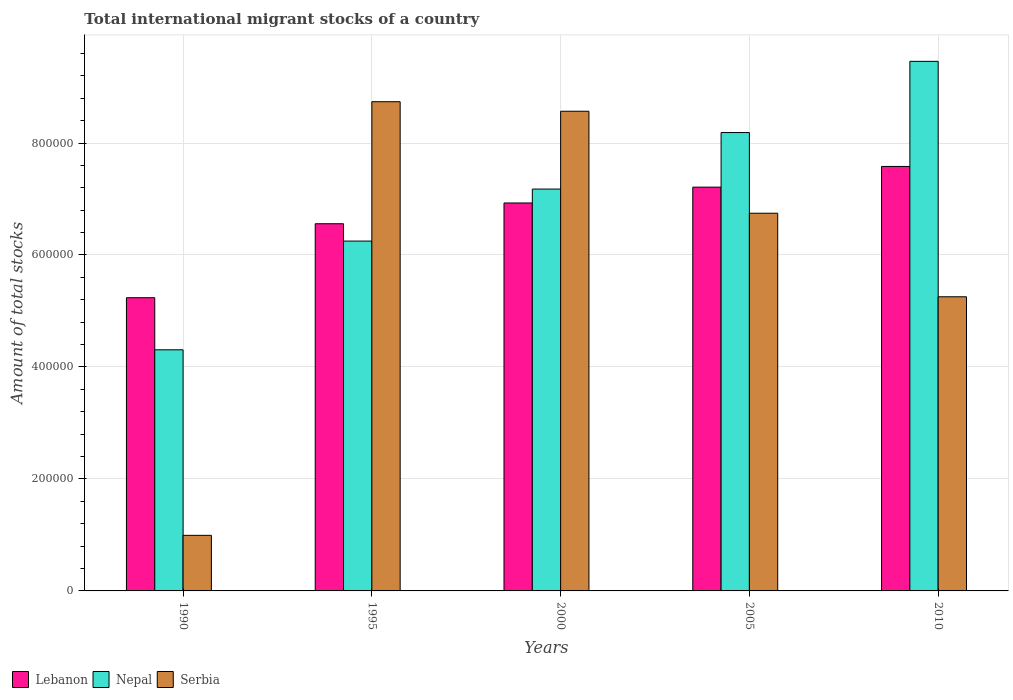How many different coloured bars are there?
Give a very brief answer. 3. How many groups of bars are there?
Your answer should be compact. 5. Are the number of bars on each tick of the X-axis equal?
Your response must be concise. Yes. How many bars are there on the 4th tick from the left?
Give a very brief answer. 3. How many bars are there on the 2nd tick from the right?
Offer a very short reply. 3. What is the amount of total stocks in in Nepal in 2010?
Offer a very short reply. 9.46e+05. Across all years, what is the maximum amount of total stocks in in Serbia?
Give a very brief answer. 8.74e+05. Across all years, what is the minimum amount of total stocks in in Lebanon?
Provide a succinct answer. 5.24e+05. In which year was the amount of total stocks in in Serbia minimum?
Ensure brevity in your answer.  1990. What is the total amount of total stocks in in Nepal in the graph?
Your response must be concise. 3.54e+06. What is the difference between the amount of total stocks in in Serbia in 1995 and that in 2010?
Offer a terse response. 3.48e+05. What is the difference between the amount of total stocks in in Serbia in 2010 and the amount of total stocks in in Lebanon in 1990?
Your answer should be very brief. 1695. What is the average amount of total stocks in in Serbia per year?
Offer a terse response. 6.06e+05. In the year 2000, what is the difference between the amount of total stocks in in Lebanon and amount of total stocks in in Nepal?
Provide a short and direct response. -2.48e+04. What is the ratio of the amount of total stocks in in Serbia in 1990 to that in 1995?
Provide a succinct answer. 0.11. Is the amount of total stocks in in Lebanon in 1990 less than that in 2000?
Your answer should be very brief. Yes. Is the difference between the amount of total stocks in in Lebanon in 1995 and 2010 greater than the difference between the amount of total stocks in in Nepal in 1995 and 2010?
Give a very brief answer. Yes. What is the difference between the highest and the second highest amount of total stocks in in Lebanon?
Give a very brief answer. 3.70e+04. What is the difference between the highest and the lowest amount of total stocks in in Lebanon?
Your answer should be very brief. 2.34e+05. In how many years, is the amount of total stocks in in Serbia greater than the average amount of total stocks in in Serbia taken over all years?
Offer a very short reply. 3. Is the sum of the amount of total stocks in in Nepal in 1990 and 2010 greater than the maximum amount of total stocks in in Lebanon across all years?
Your answer should be very brief. Yes. What does the 2nd bar from the left in 2005 represents?
Offer a terse response. Nepal. What does the 1st bar from the right in 1990 represents?
Provide a short and direct response. Serbia. Is it the case that in every year, the sum of the amount of total stocks in in Serbia and amount of total stocks in in Nepal is greater than the amount of total stocks in in Lebanon?
Give a very brief answer. Yes. Are all the bars in the graph horizontal?
Provide a succinct answer. No. Does the graph contain any zero values?
Offer a very short reply. No. Does the graph contain grids?
Provide a short and direct response. Yes. Where does the legend appear in the graph?
Make the answer very short. Bottom left. How many legend labels are there?
Give a very brief answer. 3. How are the legend labels stacked?
Your answer should be very brief. Horizontal. What is the title of the graph?
Your response must be concise. Total international migrant stocks of a country. What is the label or title of the X-axis?
Your response must be concise. Years. What is the label or title of the Y-axis?
Make the answer very short. Amount of total stocks. What is the Amount of total stocks in Lebanon in 1990?
Offer a very short reply. 5.24e+05. What is the Amount of total stocks in Nepal in 1990?
Ensure brevity in your answer.  4.31e+05. What is the Amount of total stocks of Serbia in 1990?
Offer a very short reply. 9.93e+04. What is the Amount of total stocks in Lebanon in 1995?
Ensure brevity in your answer.  6.56e+05. What is the Amount of total stocks in Nepal in 1995?
Give a very brief answer. 6.25e+05. What is the Amount of total stocks of Serbia in 1995?
Provide a succinct answer. 8.74e+05. What is the Amount of total stocks in Lebanon in 2000?
Provide a short and direct response. 6.93e+05. What is the Amount of total stocks in Nepal in 2000?
Give a very brief answer. 7.18e+05. What is the Amount of total stocks in Serbia in 2000?
Provide a succinct answer. 8.57e+05. What is the Amount of total stocks in Lebanon in 2005?
Offer a terse response. 7.21e+05. What is the Amount of total stocks of Nepal in 2005?
Provide a succinct answer. 8.19e+05. What is the Amount of total stocks of Serbia in 2005?
Your answer should be very brief. 6.75e+05. What is the Amount of total stocks of Lebanon in 2010?
Provide a short and direct response. 7.58e+05. What is the Amount of total stocks of Nepal in 2010?
Make the answer very short. 9.46e+05. What is the Amount of total stocks of Serbia in 2010?
Provide a short and direct response. 5.25e+05. Across all years, what is the maximum Amount of total stocks in Lebanon?
Provide a short and direct response. 7.58e+05. Across all years, what is the maximum Amount of total stocks in Nepal?
Provide a short and direct response. 9.46e+05. Across all years, what is the maximum Amount of total stocks in Serbia?
Provide a short and direct response. 8.74e+05. Across all years, what is the minimum Amount of total stocks in Lebanon?
Your response must be concise. 5.24e+05. Across all years, what is the minimum Amount of total stocks in Nepal?
Give a very brief answer. 4.31e+05. Across all years, what is the minimum Amount of total stocks in Serbia?
Offer a very short reply. 9.93e+04. What is the total Amount of total stocks in Lebanon in the graph?
Keep it short and to the point. 3.35e+06. What is the total Amount of total stocks in Nepal in the graph?
Provide a succinct answer. 3.54e+06. What is the total Amount of total stocks in Serbia in the graph?
Provide a short and direct response. 3.03e+06. What is the difference between the Amount of total stocks of Lebanon in 1990 and that in 1995?
Give a very brief answer. -1.32e+05. What is the difference between the Amount of total stocks of Nepal in 1990 and that in 1995?
Offer a very short reply. -1.94e+05. What is the difference between the Amount of total stocks of Serbia in 1990 and that in 1995?
Your answer should be compact. -7.75e+05. What is the difference between the Amount of total stocks of Lebanon in 1990 and that in 2000?
Provide a short and direct response. -1.69e+05. What is the difference between the Amount of total stocks in Nepal in 1990 and that in 2000?
Provide a short and direct response. -2.87e+05. What is the difference between the Amount of total stocks of Serbia in 1990 and that in 2000?
Your answer should be very brief. -7.57e+05. What is the difference between the Amount of total stocks in Lebanon in 1990 and that in 2005?
Keep it short and to the point. -1.97e+05. What is the difference between the Amount of total stocks of Nepal in 1990 and that in 2005?
Give a very brief answer. -3.88e+05. What is the difference between the Amount of total stocks in Serbia in 1990 and that in 2005?
Give a very brief answer. -5.75e+05. What is the difference between the Amount of total stocks of Lebanon in 1990 and that in 2010?
Your response must be concise. -2.34e+05. What is the difference between the Amount of total stocks in Nepal in 1990 and that in 2010?
Offer a terse response. -5.15e+05. What is the difference between the Amount of total stocks of Serbia in 1990 and that in 2010?
Your response must be concise. -4.26e+05. What is the difference between the Amount of total stocks in Lebanon in 1995 and that in 2000?
Offer a very short reply. -3.71e+04. What is the difference between the Amount of total stocks of Nepal in 1995 and that in 2000?
Keep it short and to the point. -9.29e+04. What is the difference between the Amount of total stocks of Serbia in 1995 and that in 2000?
Your answer should be compact. 1.70e+04. What is the difference between the Amount of total stocks of Lebanon in 1995 and that in 2005?
Keep it short and to the point. -6.54e+04. What is the difference between the Amount of total stocks in Nepal in 1995 and that in 2005?
Keep it short and to the point. -1.94e+05. What is the difference between the Amount of total stocks in Serbia in 1995 and that in 2005?
Offer a terse response. 1.99e+05. What is the difference between the Amount of total stocks in Lebanon in 1995 and that in 2010?
Your answer should be compact. -1.02e+05. What is the difference between the Amount of total stocks in Nepal in 1995 and that in 2010?
Provide a short and direct response. -3.21e+05. What is the difference between the Amount of total stocks in Serbia in 1995 and that in 2010?
Offer a terse response. 3.48e+05. What is the difference between the Amount of total stocks of Lebanon in 2000 and that in 2005?
Give a very brief answer. -2.83e+04. What is the difference between the Amount of total stocks in Nepal in 2000 and that in 2005?
Offer a very short reply. -1.01e+05. What is the difference between the Amount of total stocks in Serbia in 2000 and that in 2005?
Make the answer very short. 1.82e+05. What is the difference between the Amount of total stocks of Lebanon in 2000 and that in 2010?
Keep it short and to the point. -6.53e+04. What is the difference between the Amount of total stocks in Nepal in 2000 and that in 2010?
Ensure brevity in your answer.  -2.28e+05. What is the difference between the Amount of total stocks in Serbia in 2000 and that in 2010?
Keep it short and to the point. 3.31e+05. What is the difference between the Amount of total stocks in Lebanon in 2005 and that in 2010?
Provide a short and direct response. -3.70e+04. What is the difference between the Amount of total stocks of Nepal in 2005 and that in 2010?
Your answer should be very brief. -1.27e+05. What is the difference between the Amount of total stocks of Serbia in 2005 and that in 2010?
Provide a succinct answer. 1.49e+05. What is the difference between the Amount of total stocks of Lebanon in 1990 and the Amount of total stocks of Nepal in 1995?
Your answer should be compact. -1.01e+05. What is the difference between the Amount of total stocks in Lebanon in 1990 and the Amount of total stocks in Serbia in 1995?
Provide a succinct answer. -3.50e+05. What is the difference between the Amount of total stocks in Nepal in 1990 and the Amount of total stocks in Serbia in 1995?
Your answer should be compact. -4.43e+05. What is the difference between the Amount of total stocks of Lebanon in 1990 and the Amount of total stocks of Nepal in 2000?
Provide a succinct answer. -1.94e+05. What is the difference between the Amount of total stocks of Lebanon in 1990 and the Amount of total stocks of Serbia in 2000?
Make the answer very short. -3.33e+05. What is the difference between the Amount of total stocks of Nepal in 1990 and the Amount of total stocks of Serbia in 2000?
Ensure brevity in your answer.  -4.26e+05. What is the difference between the Amount of total stocks of Lebanon in 1990 and the Amount of total stocks of Nepal in 2005?
Offer a terse response. -2.95e+05. What is the difference between the Amount of total stocks in Lebanon in 1990 and the Amount of total stocks in Serbia in 2005?
Offer a very short reply. -1.51e+05. What is the difference between the Amount of total stocks of Nepal in 1990 and the Amount of total stocks of Serbia in 2005?
Offer a terse response. -2.44e+05. What is the difference between the Amount of total stocks in Lebanon in 1990 and the Amount of total stocks in Nepal in 2010?
Provide a succinct answer. -4.22e+05. What is the difference between the Amount of total stocks in Lebanon in 1990 and the Amount of total stocks in Serbia in 2010?
Your answer should be very brief. -1695. What is the difference between the Amount of total stocks in Nepal in 1990 and the Amount of total stocks in Serbia in 2010?
Give a very brief answer. -9.47e+04. What is the difference between the Amount of total stocks of Lebanon in 1995 and the Amount of total stocks of Nepal in 2000?
Provide a succinct answer. -6.19e+04. What is the difference between the Amount of total stocks of Lebanon in 1995 and the Amount of total stocks of Serbia in 2000?
Provide a succinct answer. -2.01e+05. What is the difference between the Amount of total stocks of Nepal in 1995 and the Amount of total stocks of Serbia in 2000?
Your answer should be very brief. -2.32e+05. What is the difference between the Amount of total stocks of Lebanon in 1995 and the Amount of total stocks of Nepal in 2005?
Give a very brief answer. -1.63e+05. What is the difference between the Amount of total stocks in Lebanon in 1995 and the Amount of total stocks in Serbia in 2005?
Offer a very short reply. -1.88e+04. What is the difference between the Amount of total stocks of Nepal in 1995 and the Amount of total stocks of Serbia in 2005?
Offer a terse response. -4.97e+04. What is the difference between the Amount of total stocks in Lebanon in 1995 and the Amount of total stocks in Nepal in 2010?
Offer a very short reply. -2.90e+05. What is the difference between the Amount of total stocks in Lebanon in 1995 and the Amount of total stocks in Serbia in 2010?
Make the answer very short. 1.30e+05. What is the difference between the Amount of total stocks of Nepal in 1995 and the Amount of total stocks of Serbia in 2010?
Your answer should be compact. 9.95e+04. What is the difference between the Amount of total stocks of Lebanon in 2000 and the Amount of total stocks of Nepal in 2005?
Ensure brevity in your answer.  -1.26e+05. What is the difference between the Amount of total stocks of Lebanon in 2000 and the Amount of total stocks of Serbia in 2005?
Provide a succinct answer. 1.83e+04. What is the difference between the Amount of total stocks in Nepal in 2000 and the Amount of total stocks in Serbia in 2005?
Your answer should be compact. 4.31e+04. What is the difference between the Amount of total stocks of Lebanon in 2000 and the Amount of total stocks of Nepal in 2010?
Ensure brevity in your answer.  -2.53e+05. What is the difference between the Amount of total stocks in Lebanon in 2000 and the Amount of total stocks in Serbia in 2010?
Ensure brevity in your answer.  1.68e+05. What is the difference between the Amount of total stocks in Nepal in 2000 and the Amount of total stocks in Serbia in 2010?
Your answer should be compact. 1.92e+05. What is the difference between the Amount of total stocks in Lebanon in 2005 and the Amount of total stocks in Nepal in 2010?
Offer a terse response. -2.25e+05. What is the difference between the Amount of total stocks of Lebanon in 2005 and the Amount of total stocks of Serbia in 2010?
Your answer should be compact. 1.96e+05. What is the difference between the Amount of total stocks of Nepal in 2005 and the Amount of total stocks of Serbia in 2010?
Make the answer very short. 2.93e+05. What is the average Amount of total stocks in Lebanon per year?
Ensure brevity in your answer.  6.70e+05. What is the average Amount of total stocks in Nepal per year?
Your response must be concise. 7.08e+05. What is the average Amount of total stocks in Serbia per year?
Provide a succinct answer. 6.06e+05. In the year 1990, what is the difference between the Amount of total stocks of Lebanon and Amount of total stocks of Nepal?
Keep it short and to the point. 9.30e+04. In the year 1990, what is the difference between the Amount of total stocks of Lebanon and Amount of total stocks of Serbia?
Give a very brief answer. 4.24e+05. In the year 1990, what is the difference between the Amount of total stocks in Nepal and Amount of total stocks in Serbia?
Ensure brevity in your answer.  3.31e+05. In the year 1995, what is the difference between the Amount of total stocks in Lebanon and Amount of total stocks in Nepal?
Give a very brief answer. 3.10e+04. In the year 1995, what is the difference between the Amount of total stocks of Lebanon and Amount of total stocks of Serbia?
Ensure brevity in your answer.  -2.18e+05. In the year 1995, what is the difference between the Amount of total stocks of Nepal and Amount of total stocks of Serbia?
Provide a short and direct response. -2.49e+05. In the year 2000, what is the difference between the Amount of total stocks of Lebanon and Amount of total stocks of Nepal?
Your answer should be compact. -2.48e+04. In the year 2000, what is the difference between the Amount of total stocks in Lebanon and Amount of total stocks in Serbia?
Offer a terse response. -1.64e+05. In the year 2000, what is the difference between the Amount of total stocks in Nepal and Amount of total stocks in Serbia?
Give a very brief answer. -1.39e+05. In the year 2005, what is the difference between the Amount of total stocks of Lebanon and Amount of total stocks of Nepal?
Provide a short and direct response. -9.75e+04. In the year 2005, what is the difference between the Amount of total stocks in Lebanon and Amount of total stocks in Serbia?
Your response must be concise. 4.66e+04. In the year 2005, what is the difference between the Amount of total stocks of Nepal and Amount of total stocks of Serbia?
Offer a very short reply. 1.44e+05. In the year 2010, what is the difference between the Amount of total stocks in Lebanon and Amount of total stocks in Nepal?
Your answer should be very brief. -1.88e+05. In the year 2010, what is the difference between the Amount of total stocks of Lebanon and Amount of total stocks of Serbia?
Ensure brevity in your answer.  2.33e+05. In the year 2010, what is the difference between the Amount of total stocks in Nepal and Amount of total stocks in Serbia?
Keep it short and to the point. 4.20e+05. What is the ratio of the Amount of total stocks in Lebanon in 1990 to that in 1995?
Your answer should be very brief. 0.8. What is the ratio of the Amount of total stocks in Nepal in 1990 to that in 1995?
Your answer should be very brief. 0.69. What is the ratio of the Amount of total stocks of Serbia in 1990 to that in 1995?
Offer a terse response. 0.11. What is the ratio of the Amount of total stocks in Lebanon in 1990 to that in 2000?
Your answer should be compact. 0.76. What is the ratio of the Amount of total stocks of Serbia in 1990 to that in 2000?
Give a very brief answer. 0.12. What is the ratio of the Amount of total stocks in Lebanon in 1990 to that in 2005?
Your answer should be compact. 0.73. What is the ratio of the Amount of total stocks in Nepal in 1990 to that in 2005?
Keep it short and to the point. 0.53. What is the ratio of the Amount of total stocks in Serbia in 1990 to that in 2005?
Your answer should be compact. 0.15. What is the ratio of the Amount of total stocks of Lebanon in 1990 to that in 2010?
Ensure brevity in your answer.  0.69. What is the ratio of the Amount of total stocks of Nepal in 1990 to that in 2010?
Your answer should be very brief. 0.46. What is the ratio of the Amount of total stocks of Serbia in 1990 to that in 2010?
Your response must be concise. 0.19. What is the ratio of the Amount of total stocks of Lebanon in 1995 to that in 2000?
Ensure brevity in your answer.  0.95. What is the ratio of the Amount of total stocks in Nepal in 1995 to that in 2000?
Ensure brevity in your answer.  0.87. What is the ratio of the Amount of total stocks in Serbia in 1995 to that in 2000?
Provide a succinct answer. 1.02. What is the ratio of the Amount of total stocks in Lebanon in 1995 to that in 2005?
Your response must be concise. 0.91. What is the ratio of the Amount of total stocks of Nepal in 1995 to that in 2005?
Your response must be concise. 0.76. What is the ratio of the Amount of total stocks of Serbia in 1995 to that in 2005?
Offer a very short reply. 1.3. What is the ratio of the Amount of total stocks in Lebanon in 1995 to that in 2010?
Give a very brief answer. 0.86. What is the ratio of the Amount of total stocks in Nepal in 1995 to that in 2010?
Keep it short and to the point. 0.66. What is the ratio of the Amount of total stocks of Serbia in 1995 to that in 2010?
Your response must be concise. 1.66. What is the ratio of the Amount of total stocks of Lebanon in 2000 to that in 2005?
Offer a very short reply. 0.96. What is the ratio of the Amount of total stocks in Nepal in 2000 to that in 2005?
Offer a terse response. 0.88. What is the ratio of the Amount of total stocks in Serbia in 2000 to that in 2005?
Offer a terse response. 1.27. What is the ratio of the Amount of total stocks of Lebanon in 2000 to that in 2010?
Your answer should be very brief. 0.91. What is the ratio of the Amount of total stocks in Nepal in 2000 to that in 2010?
Ensure brevity in your answer.  0.76. What is the ratio of the Amount of total stocks of Serbia in 2000 to that in 2010?
Ensure brevity in your answer.  1.63. What is the ratio of the Amount of total stocks of Lebanon in 2005 to that in 2010?
Make the answer very short. 0.95. What is the ratio of the Amount of total stocks in Nepal in 2005 to that in 2010?
Your answer should be compact. 0.87. What is the ratio of the Amount of total stocks of Serbia in 2005 to that in 2010?
Make the answer very short. 1.28. What is the difference between the highest and the second highest Amount of total stocks in Lebanon?
Keep it short and to the point. 3.70e+04. What is the difference between the highest and the second highest Amount of total stocks in Nepal?
Provide a succinct answer. 1.27e+05. What is the difference between the highest and the second highest Amount of total stocks in Serbia?
Offer a terse response. 1.70e+04. What is the difference between the highest and the lowest Amount of total stocks in Lebanon?
Keep it short and to the point. 2.34e+05. What is the difference between the highest and the lowest Amount of total stocks of Nepal?
Your answer should be compact. 5.15e+05. What is the difference between the highest and the lowest Amount of total stocks of Serbia?
Your response must be concise. 7.75e+05. 